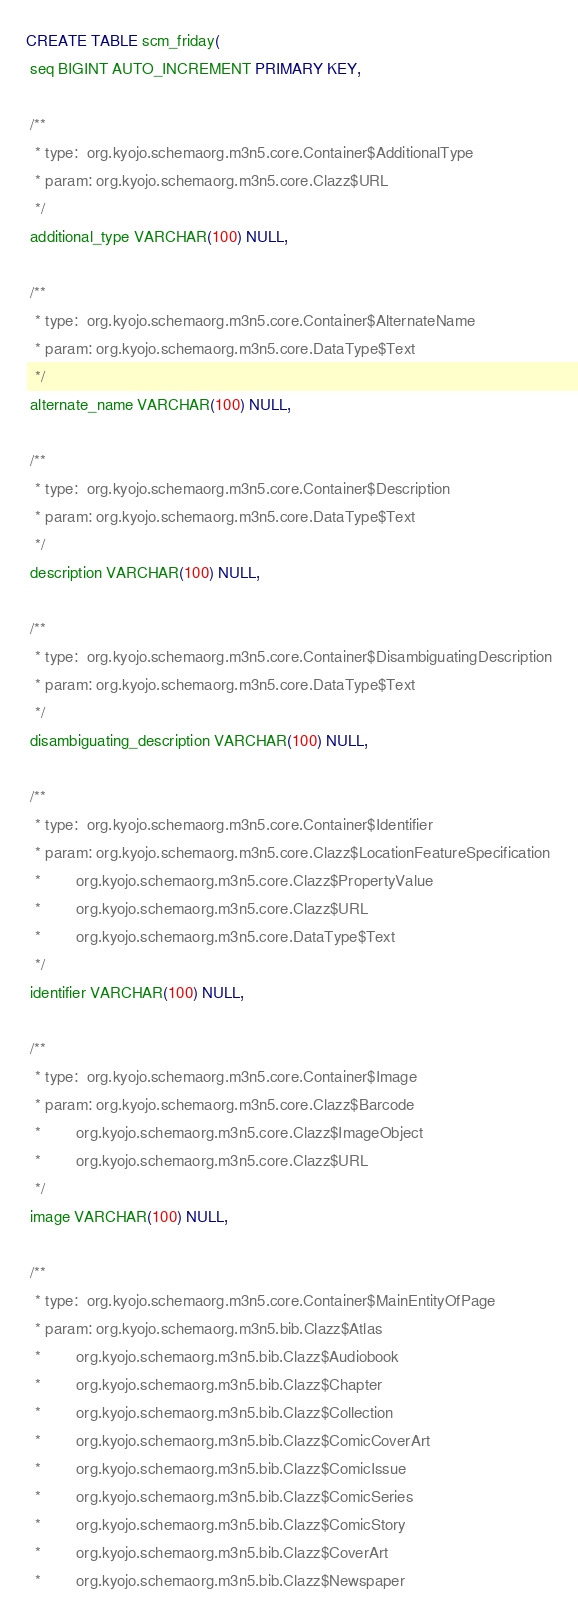<code> <loc_0><loc_0><loc_500><loc_500><_SQL_>CREATE TABLE scm_friday(
 seq BIGINT AUTO_INCREMENT PRIMARY KEY,

 /**
  * type:  org.kyojo.schemaorg.m3n5.core.Container$AdditionalType
  * param: org.kyojo.schemaorg.m3n5.core.Clazz$URL
  */
 additional_type VARCHAR(100) NULL,

 /**
  * type:  org.kyojo.schemaorg.m3n5.core.Container$AlternateName
  * param: org.kyojo.schemaorg.m3n5.core.DataType$Text
  */
 alternate_name VARCHAR(100) NULL,

 /**
  * type:  org.kyojo.schemaorg.m3n5.core.Container$Description
  * param: org.kyojo.schemaorg.m3n5.core.DataType$Text
  */
 description VARCHAR(100) NULL,

 /**
  * type:  org.kyojo.schemaorg.m3n5.core.Container$DisambiguatingDescription
  * param: org.kyojo.schemaorg.m3n5.core.DataType$Text
  */
 disambiguating_description VARCHAR(100) NULL,

 /**
  * type:  org.kyojo.schemaorg.m3n5.core.Container$Identifier
  * param: org.kyojo.schemaorg.m3n5.core.Clazz$LocationFeatureSpecification
  *        org.kyojo.schemaorg.m3n5.core.Clazz$PropertyValue
  *        org.kyojo.schemaorg.m3n5.core.Clazz$URL
  *        org.kyojo.schemaorg.m3n5.core.DataType$Text
  */
 identifier VARCHAR(100) NULL,

 /**
  * type:  org.kyojo.schemaorg.m3n5.core.Container$Image
  * param: org.kyojo.schemaorg.m3n5.core.Clazz$Barcode
  *        org.kyojo.schemaorg.m3n5.core.Clazz$ImageObject
  *        org.kyojo.schemaorg.m3n5.core.Clazz$URL
  */
 image VARCHAR(100) NULL,

 /**
  * type:  org.kyojo.schemaorg.m3n5.core.Container$MainEntityOfPage
  * param: org.kyojo.schemaorg.m3n5.bib.Clazz$Atlas
  *        org.kyojo.schemaorg.m3n5.bib.Clazz$Audiobook
  *        org.kyojo.schemaorg.m3n5.bib.Clazz$Chapter
  *        org.kyojo.schemaorg.m3n5.bib.Clazz$Collection
  *        org.kyojo.schemaorg.m3n5.bib.Clazz$ComicCoverArt
  *        org.kyojo.schemaorg.m3n5.bib.Clazz$ComicIssue
  *        org.kyojo.schemaorg.m3n5.bib.Clazz$ComicSeries
  *        org.kyojo.schemaorg.m3n5.bib.Clazz$ComicStory
  *        org.kyojo.schemaorg.m3n5.bib.Clazz$CoverArt
  *        org.kyojo.schemaorg.m3n5.bib.Clazz$Newspaper</code> 